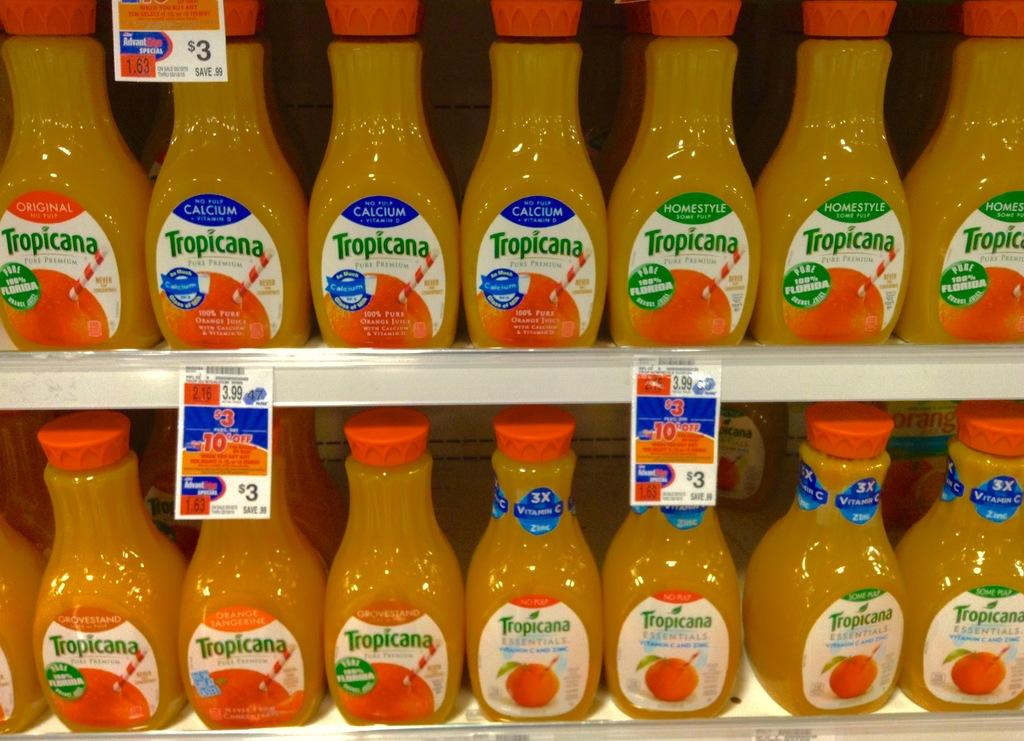What objects are visible in the image? There are bottles in the image. How are the bottles arranged? The bottles are arranged on a shelf. What information can be found on the bottles? There is labeling on the bottles. Is there a volcano erupting in the background of the image? No, there is no volcano or any indication of an eruption in the image. 